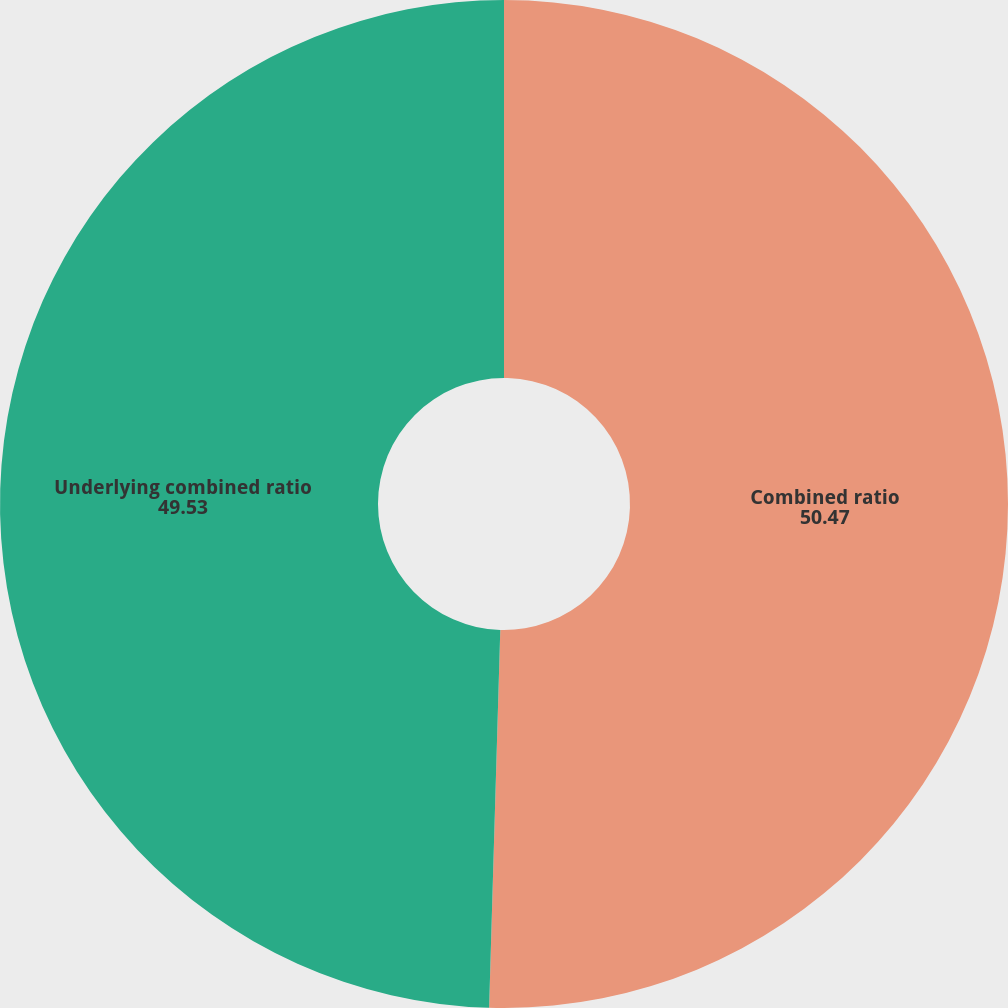Convert chart to OTSL. <chart><loc_0><loc_0><loc_500><loc_500><pie_chart><fcel>Combined ratio<fcel>Underlying combined ratio<nl><fcel>50.47%<fcel>49.53%<nl></chart> 